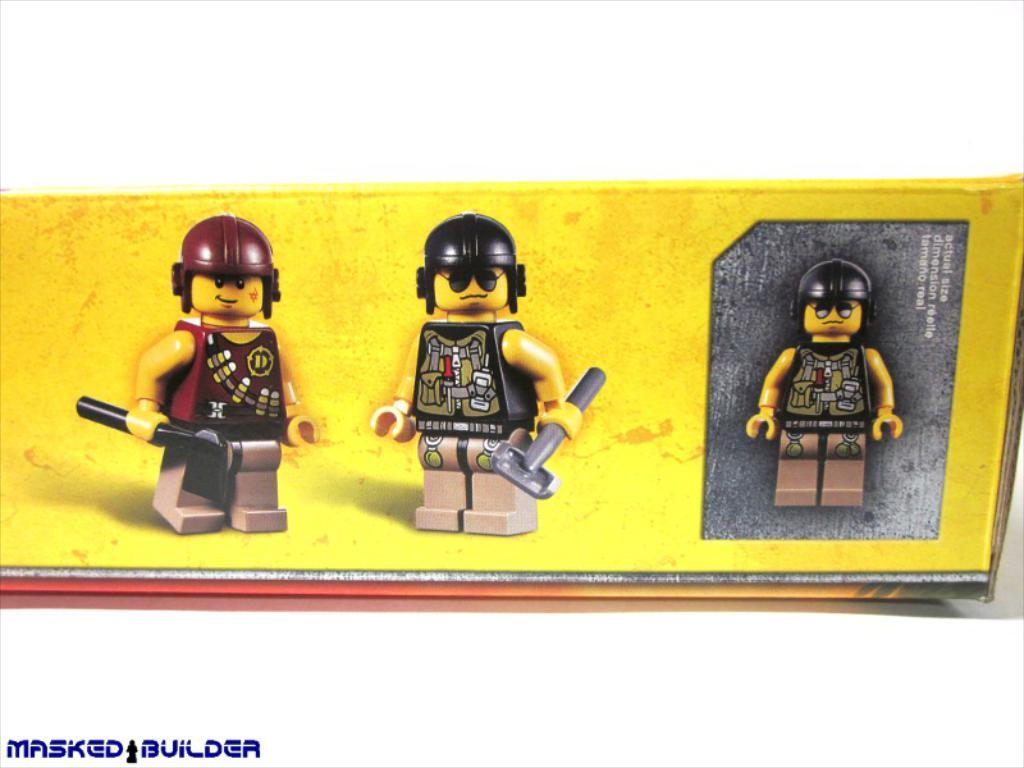What objects are located in the middle of the image? There are three toys in the middle of the image. What is the toys resting on? The toys are on a cardboard box. What can be found on the cardboard box besides the toys? There is text on the cardboard box. What color is the background of the image? The background of the image is white in color. What type of steel is used to make the grandmother's shoe in the image? There is no grandmother or shoe present in the image, so it is not possible to determine the type of steel used. 